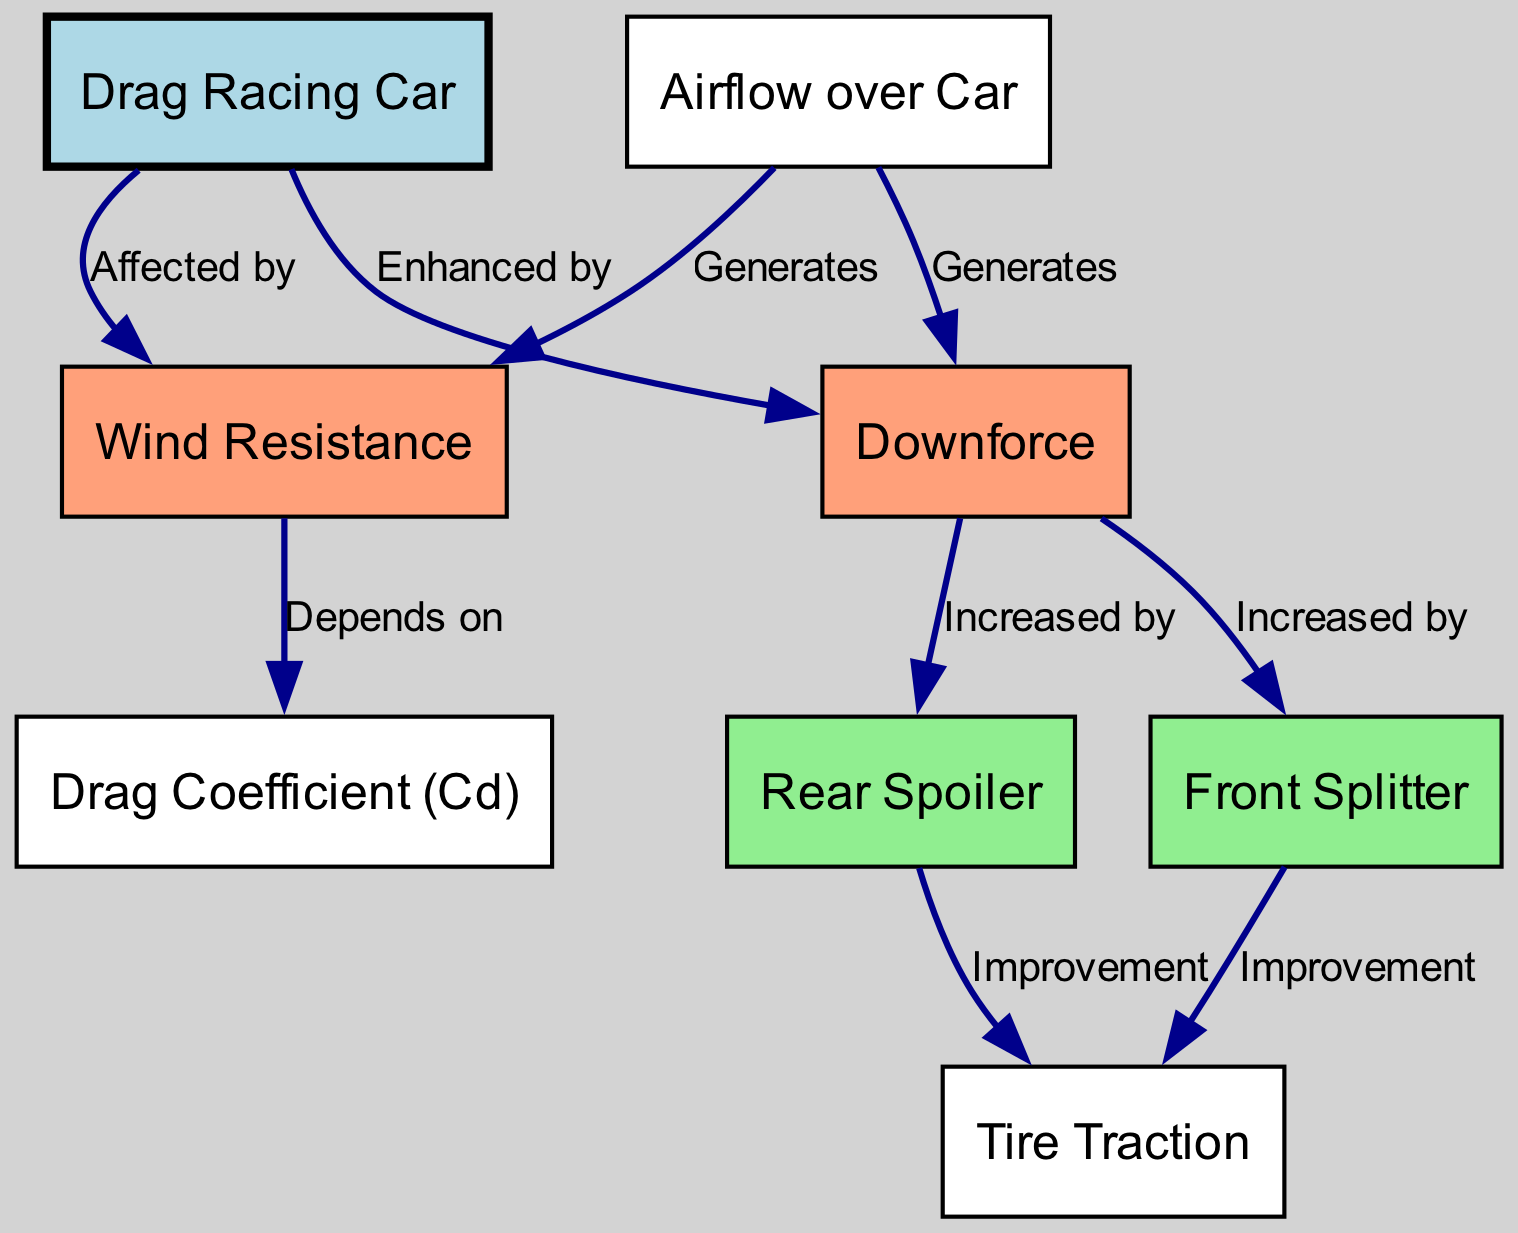What is the primary force opposing the motion of a drag racing car? The diagram specifies "Wind Resistance" as the opposing force, directly linked from "Drag Racing Car" to "Wind Resistance" with the label "Affected by."
Answer: Wind Resistance Which aerodynamic devices are used to increase downforce on the drag racing car? The diagram indicates two devices increasing downforce: "Front Splitter," which is linked to "Downforce" with the label "Increased by," and "Rear Spoiler," which shares a similar connection.
Answer: Front Splitter and Rear Spoiler What does a higher Drag Coefficient indicate in terms of wind resistance? The diagram clarifies that "Wind Resistance" depends on "Drag Coefficient (Cd)," where an increased drag coefficient results in greater wind resistance.
Answer: More wind resistance How do the Front Splitter and Rear Spoiler relate to tire traction? The diagram shows that both the "Front Splitter" and "Rear Spoiler" link to "Tire Traction," emphasizing that they improve tire traction through their respective downforce contributions.
Answer: Improve tire traction What node measures the aerodynamic efficiency of a drag racing car? The diagram directly points to "Drag Coefficient (Cd)" as the measurement of aerodynamic efficiency, indicated by its label within the diagram.
Answer: Drag Coefficient (Cd) How many edges connect "Airflow over Car" to other nodes in the diagram? Analyzing the diagram reveals that "Airflow over Car" connects to two nodes: "Wind Resistance" and "Downforce," demonstrating its role in generating both effects.
Answer: Two Which node represents the friction between tires and the track surface? The diagram clearly identifies "Tire Traction" as the node that describes the friction between tires and the track surface, which is connected to other aerodynamic aspects.
Answer: Tire Traction What generates downforce in a drag racing car according to the diagram? The diagram states that "Airflow over Car" generates downforce, connecting to "Downforce" with the label "Generates," indicating the airflow’s role in this effect.
Answer: Airflow over Car Which factor does higher Drag Coefficient correlate with according to the diagram? The diagram specifies that higher Drag Coefficient correlates with greater "Wind Resistance," suggesting a direct dependency between these two attributes in aerodynamics.
Answer: More wind resistance 